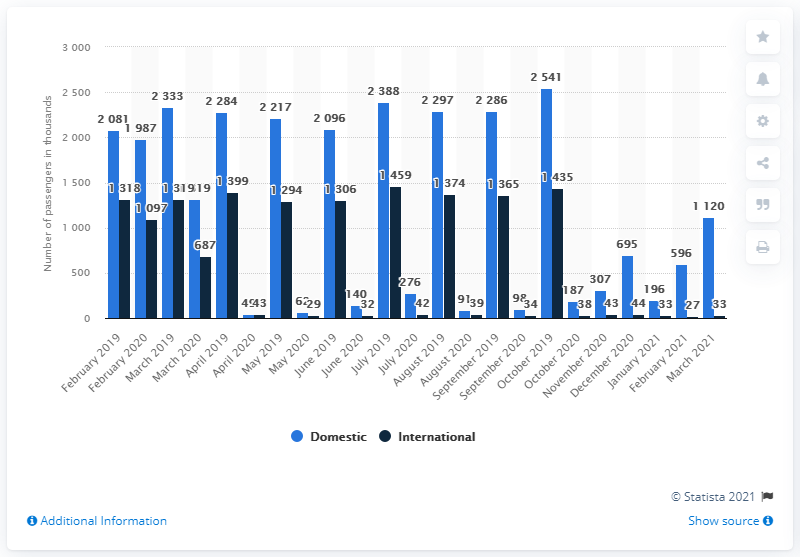Highlight a few significant elements in this photo. The Sydney Kingsford Smith International Airport recorded 1,319,000 domestic passengers in March 2021. In March 2021, there was a reduction of 42% in the number of domestic passengers at Sydney Kingsford Smith International Airport. 